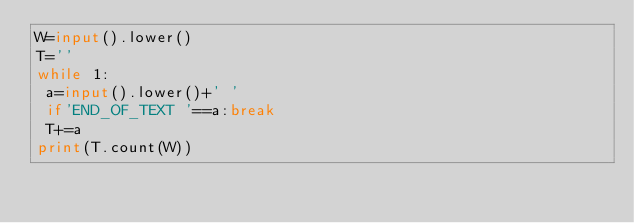Convert code to text. <code><loc_0><loc_0><loc_500><loc_500><_Python_>W=input().lower()
T=''
while 1:
 a=input().lower()+' '
 if'END_OF_TEXT '==a:break
 T+=a
print(T.count(W))</code> 